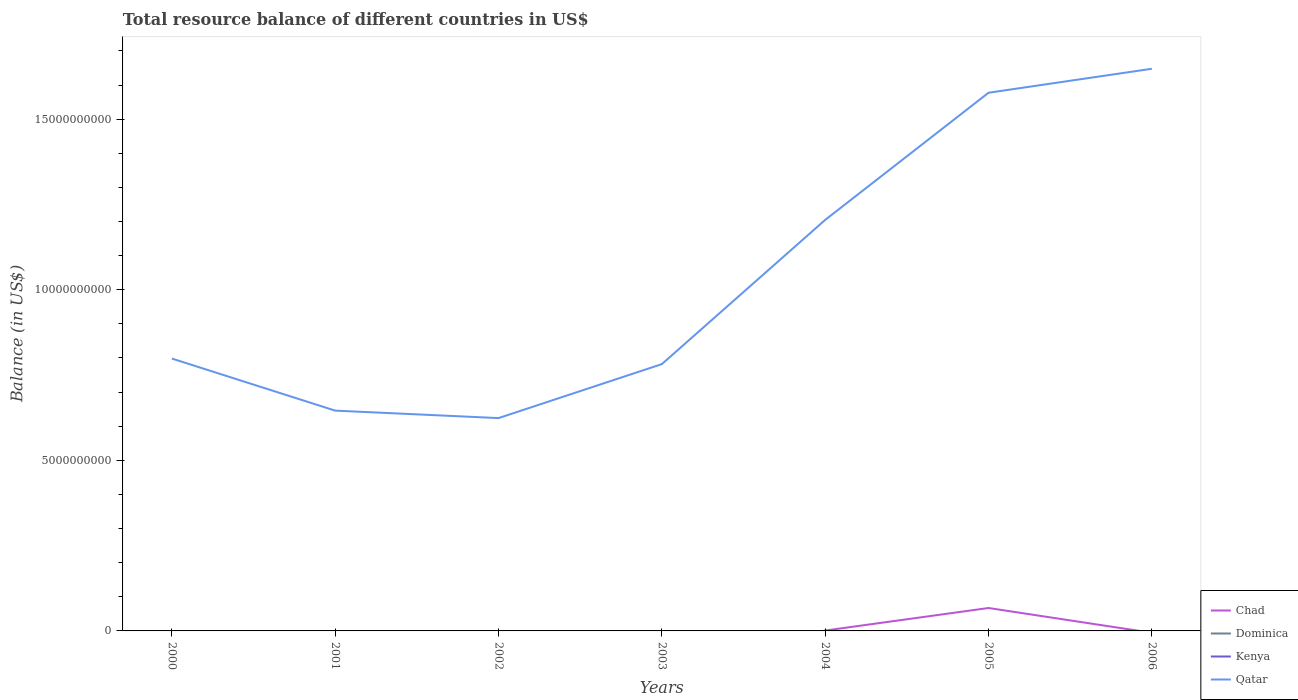Across all years, what is the maximum total resource balance in Qatar?
Give a very brief answer. 6.24e+09. What is the total total resource balance in Chad in the graph?
Your answer should be very brief. -6.61e+08. What is the difference between the highest and the second highest total resource balance in Qatar?
Provide a succinct answer. 1.02e+1. Is the total resource balance in Kenya strictly greater than the total resource balance in Dominica over the years?
Ensure brevity in your answer.  Yes. How many lines are there?
Your answer should be very brief. 2. How many years are there in the graph?
Keep it short and to the point. 7. What is the difference between two consecutive major ticks on the Y-axis?
Ensure brevity in your answer.  5.00e+09. Does the graph contain any zero values?
Provide a short and direct response. Yes. How many legend labels are there?
Your answer should be compact. 4. How are the legend labels stacked?
Ensure brevity in your answer.  Vertical. What is the title of the graph?
Give a very brief answer. Total resource balance of different countries in US$. Does "New Caledonia" appear as one of the legend labels in the graph?
Make the answer very short. No. What is the label or title of the X-axis?
Offer a terse response. Years. What is the label or title of the Y-axis?
Provide a short and direct response. Balance (in US$). What is the Balance (in US$) of Chad in 2000?
Your answer should be compact. 0. What is the Balance (in US$) in Qatar in 2000?
Provide a succinct answer. 7.98e+09. What is the Balance (in US$) in Chad in 2001?
Give a very brief answer. 0. What is the Balance (in US$) of Dominica in 2001?
Your answer should be very brief. 0. What is the Balance (in US$) in Kenya in 2001?
Keep it short and to the point. 0. What is the Balance (in US$) in Qatar in 2001?
Provide a short and direct response. 6.46e+09. What is the Balance (in US$) in Chad in 2002?
Your answer should be very brief. 0. What is the Balance (in US$) of Qatar in 2002?
Give a very brief answer. 6.24e+09. What is the Balance (in US$) in Dominica in 2003?
Your response must be concise. 0. What is the Balance (in US$) in Kenya in 2003?
Offer a terse response. 0. What is the Balance (in US$) of Qatar in 2003?
Keep it short and to the point. 7.82e+09. What is the Balance (in US$) in Chad in 2004?
Provide a short and direct response. 1.10e+07. What is the Balance (in US$) in Dominica in 2004?
Ensure brevity in your answer.  0. What is the Balance (in US$) of Qatar in 2004?
Give a very brief answer. 1.20e+1. What is the Balance (in US$) of Chad in 2005?
Offer a terse response. 6.72e+08. What is the Balance (in US$) in Dominica in 2005?
Provide a short and direct response. 0. What is the Balance (in US$) of Qatar in 2005?
Provide a short and direct response. 1.58e+1. What is the Balance (in US$) in Dominica in 2006?
Provide a succinct answer. 0. What is the Balance (in US$) in Qatar in 2006?
Make the answer very short. 1.65e+1. Across all years, what is the maximum Balance (in US$) of Chad?
Your answer should be very brief. 6.72e+08. Across all years, what is the maximum Balance (in US$) in Qatar?
Offer a terse response. 1.65e+1. Across all years, what is the minimum Balance (in US$) of Qatar?
Make the answer very short. 6.24e+09. What is the total Balance (in US$) in Chad in the graph?
Provide a succinct answer. 6.83e+08. What is the total Balance (in US$) of Dominica in the graph?
Provide a succinct answer. 0. What is the total Balance (in US$) in Kenya in the graph?
Keep it short and to the point. 0. What is the total Balance (in US$) of Qatar in the graph?
Your response must be concise. 7.28e+1. What is the difference between the Balance (in US$) in Qatar in 2000 and that in 2001?
Provide a short and direct response. 1.53e+09. What is the difference between the Balance (in US$) of Qatar in 2000 and that in 2002?
Ensure brevity in your answer.  1.75e+09. What is the difference between the Balance (in US$) in Qatar in 2000 and that in 2003?
Provide a short and direct response. 1.63e+08. What is the difference between the Balance (in US$) in Qatar in 2000 and that in 2004?
Your answer should be very brief. -4.06e+09. What is the difference between the Balance (in US$) of Qatar in 2000 and that in 2005?
Provide a short and direct response. -7.79e+09. What is the difference between the Balance (in US$) of Qatar in 2000 and that in 2006?
Offer a terse response. -8.49e+09. What is the difference between the Balance (in US$) in Qatar in 2001 and that in 2002?
Your answer should be very brief. 2.19e+08. What is the difference between the Balance (in US$) in Qatar in 2001 and that in 2003?
Provide a short and direct response. -1.36e+09. What is the difference between the Balance (in US$) of Qatar in 2001 and that in 2004?
Give a very brief answer. -5.59e+09. What is the difference between the Balance (in US$) of Qatar in 2001 and that in 2005?
Your response must be concise. -9.32e+09. What is the difference between the Balance (in US$) of Qatar in 2001 and that in 2006?
Your answer should be compact. -1.00e+1. What is the difference between the Balance (in US$) in Qatar in 2002 and that in 2003?
Provide a short and direct response. -1.58e+09. What is the difference between the Balance (in US$) in Qatar in 2002 and that in 2004?
Offer a very short reply. -5.81e+09. What is the difference between the Balance (in US$) in Qatar in 2002 and that in 2005?
Give a very brief answer. -9.54e+09. What is the difference between the Balance (in US$) in Qatar in 2002 and that in 2006?
Provide a succinct answer. -1.02e+1. What is the difference between the Balance (in US$) of Qatar in 2003 and that in 2004?
Your answer should be compact. -4.23e+09. What is the difference between the Balance (in US$) of Qatar in 2003 and that in 2005?
Your response must be concise. -7.95e+09. What is the difference between the Balance (in US$) of Qatar in 2003 and that in 2006?
Your response must be concise. -8.66e+09. What is the difference between the Balance (in US$) in Chad in 2004 and that in 2005?
Ensure brevity in your answer.  -6.61e+08. What is the difference between the Balance (in US$) of Qatar in 2004 and that in 2005?
Offer a very short reply. -3.73e+09. What is the difference between the Balance (in US$) in Qatar in 2004 and that in 2006?
Your response must be concise. -4.43e+09. What is the difference between the Balance (in US$) of Qatar in 2005 and that in 2006?
Your answer should be compact. -7.03e+08. What is the difference between the Balance (in US$) in Chad in 2004 and the Balance (in US$) in Qatar in 2005?
Provide a succinct answer. -1.58e+1. What is the difference between the Balance (in US$) of Chad in 2004 and the Balance (in US$) of Qatar in 2006?
Ensure brevity in your answer.  -1.65e+1. What is the difference between the Balance (in US$) of Chad in 2005 and the Balance (in US$) of Qatar in 2006?
Ensure brevity in your answer.  -1.58e+1. What is the average Balance (in US$) in Chad per year?
Your response must be concise. 9.75e+07. What is the average Balance (in US$) in Kenya per year?
Your answer should be very brief. 0. What is the average Balance (in US$) in Qatar per year?
Give a very brief answer. 1.04e+1. In the year 2004, what is the difference between the Balance (in US$) in Chad and Balance (in US$) in Qatar?
Make the answer very short. -1.20e+1. In the year 2005, what is the difference between the Balance (in US$) in Chad and Balance (in US$) in Qatar?
Keep it short and to the point. -1.51e+1. What is the ratio of the Balance (in US$) in Qatar in 2000 to that in 2001?
Make the answer very short. 1.24. What is the ratio of the Balance (in US$) of Qatar in 2000 to that in 2002?
Offer a very short reply. 1.28. What is the ratio of the Balance (in US$) in Qatar in 2000 to that in 2003?
Keep it short and to the point. 1.02. What is the ratio of the Balance (in US$) of Qatar in 2000 to that in 2004?
Give a very brief answer. 0.66. What is the ratio of the Balance (in US$) of Qatar in 2000 to that in 2005?
Give a very brief answer. 0.51. What is the ratio of the Balance (in US$) in Qatar in 2000 to that in 2006?
Keep it short and to the point. 0.48. What is the ratio of the Balance (in US$) of Qatar in 2001 to that in 2002?
Your response must be concise. 1.04. What is the ratio of the Balance (in US$) of Qatar in 2001 to that in 2003?
Ensure brevity in your answer.  0.83. What is the ratio of the Balance (in US$) in Qatar in 2001 to that in 2004?
Make the answer very short. 0.54. What is the ratio of the Balance (in US$) of Qatar in 2001 to that in 2005?
Offer a very short reply. 0.41. What is the ratio of the Balance (in US$) in Qatar in 2001 to that in 2006?
Give a very brief answer. 0.39. What is the ratio of the Balance (in US$) of Qatar in 2002 to that in 2003?
Provide a succinct answer. 0.8. What is the ratio of the Balance (in US$) in Qatar in 2002 to that in 2004?
Provide a succinct answer. 0.52. What is the ratio of the Balance (in US$) in Qatar in 2002 to that in 2005?
Your answer should be compact. 0.4. What is the ratio of the Balance (in US$) of Qatar in 2002 to that in 2006?
Give a very brief answer. 0.38. What is the ratio of the Balance (in US$) in Qatar in 2003 to that in 2004?
Ensure brevity in your answer.  0.65. What is the ratio of the Balance (in US$) of Qatar in 2003 to that in 2005?
Keep it short and to the point. 0.5. What is the ratio of the Balance (in US$) of Qatar in 2003 to that in 2006?
Your answer should be compact. 0.47. What is the ratio of the Balance (in US$) in Chad in 2004 to that in 2005?
Your answer should be compact. 0.02. What is the ratio of the Balance (in US$) of Qatar in 2004 to that in 2005?
Your response must be concise. 0.76. What is the ratio of the Balance (in US$) in Qatar in 2004 to that in 2006?
Provide a short and direct response. 0.73. What is the ratio of the Balance (in US$) of Qatar in 2005 to that in 2006?
Provide a succinct answer. 0.96. What is the difference between the highest and the second highest Balance (in US$) of Qatar?
Offer a terse response. 7.03e+08. What is the difference between the highest and the lowest Balance (in US$) of Chad?
Make the answer very short. 6.72e+08. What is the difference between the highest and the lowest Balance (in US$) in Qatar?
Keep it short and to the point. 1.02e+1. 